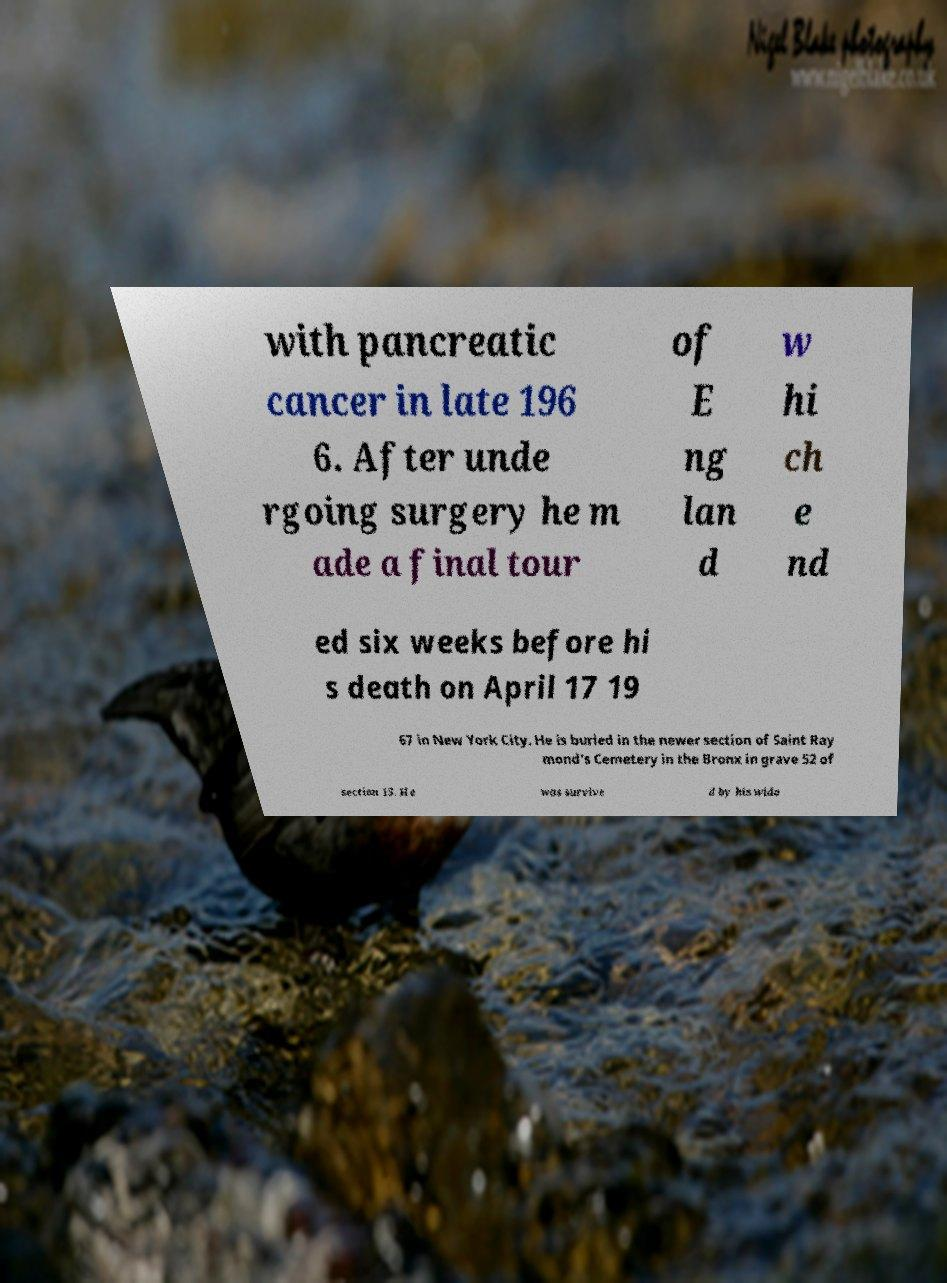Could you assist in decoding the text presented in this image and type it out clearly? with pancreatic cancer in late 196 6. After unde rgoing surgery he m ade a final tour of E ng lan d w hi ch e nd ed six weeks before hi s death on April 17 19 67 in New York City. He is buried in the newer section of Saint Ray mond's Cemetery in the Bronx in grave 52 of section 15. He was survive d by his wido 